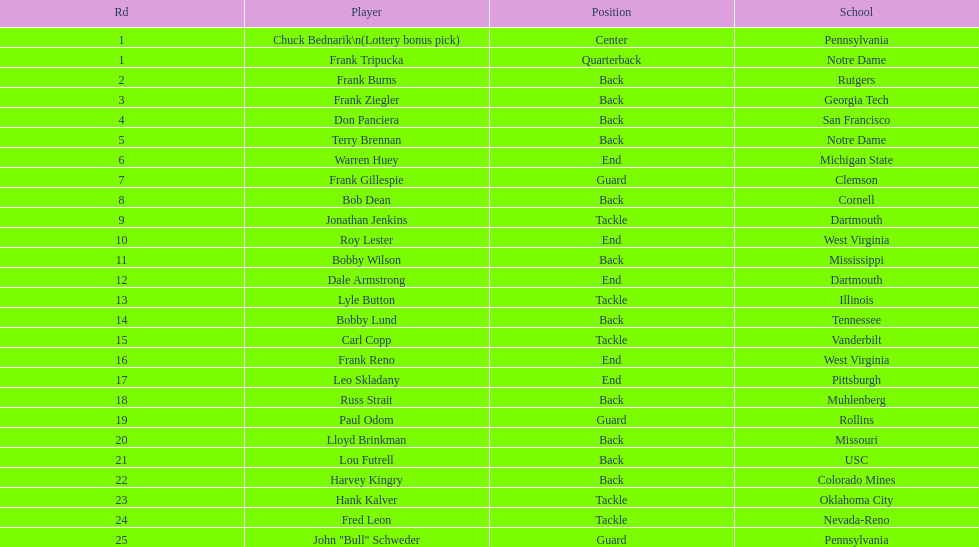Was chuck bednarik or frank tripucka the first draft pick? Chuck Bednarik. 